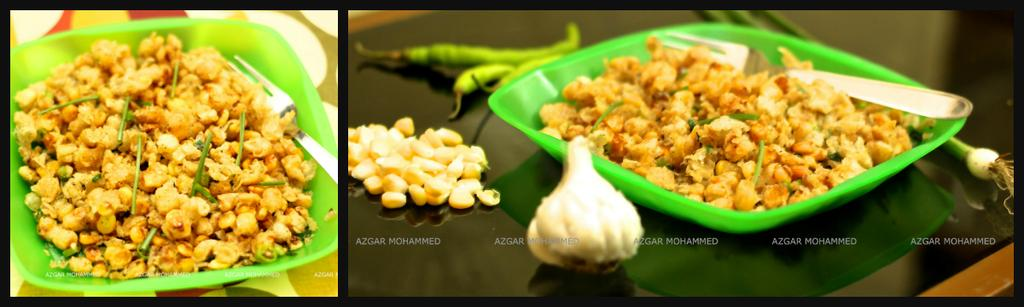What is on the plate that is visible in the image? There is food on the plate in the image. What utensil can be seen in the image? There is a fork in the image. What type of food is present on the plate? The food on the plate includes garlic. Where are all the objects in the image located? All objects are on a table in the image. What day of the week is the meeting taking place in the image? There is no meeting present in the image. Is there a bath visible in the image? There is no bath present in the image. 